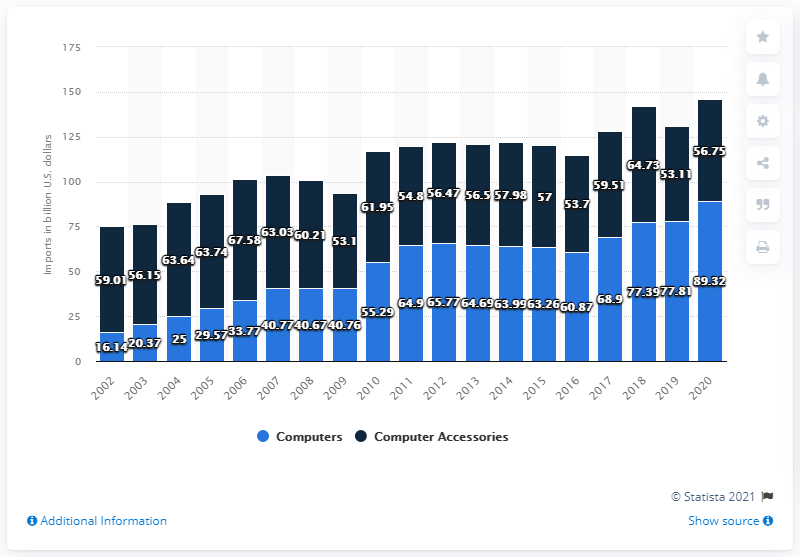Point out several critical features in this image. In 2020, the value of computer accessories imported was approximately 56.75. In the year 2002, the value difference between computer accessories and computer imports was 42.87. In 2020, the value of computer imports in the U.S. was $89.32 billion. In 2020, the value of computer accessories, peripherals, and parts imported to the United States was approximately $56.75 billion. 